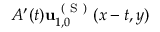<formula> <loc_0><loc_0><loc_500><loc_500>A ^ { \prime } ( t ) u _ { 1 , 0 } ^ { ( S ) } ( x - t , y )</formula> 